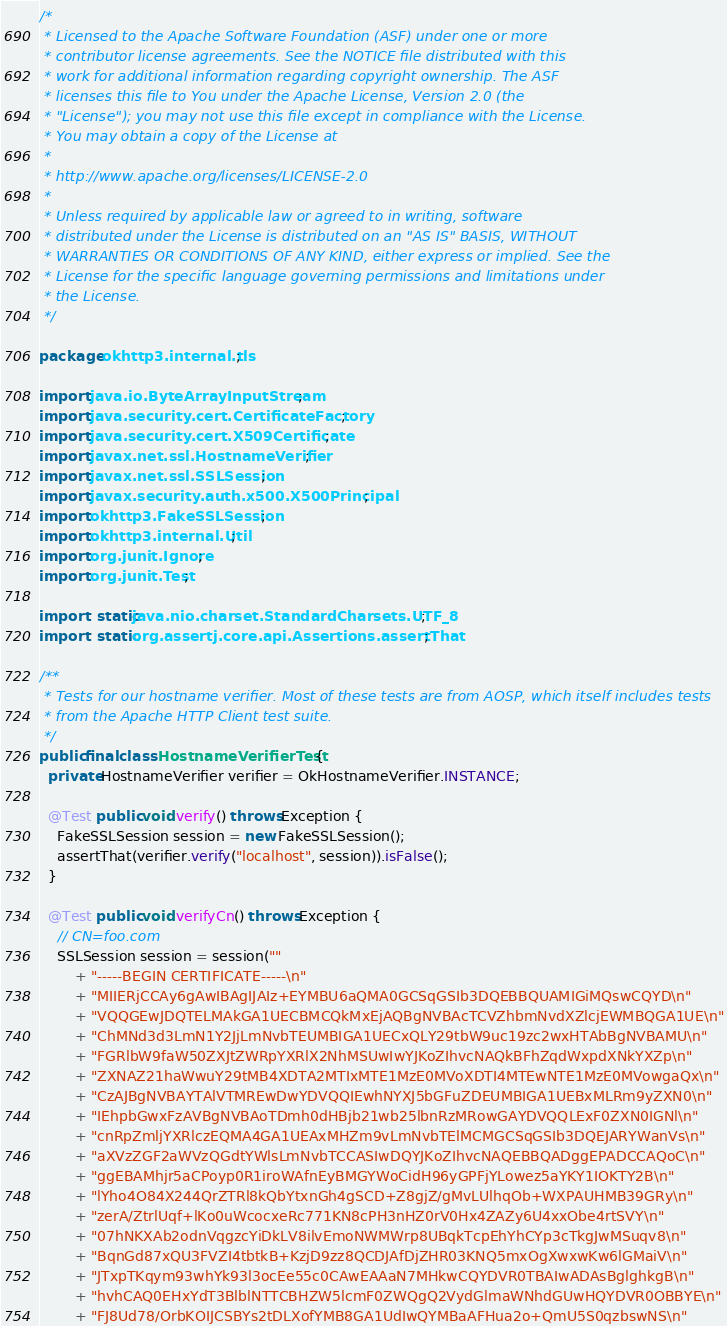<code> <loc_0><loc_0><loc_500><loc_500><_Java_>/*
 * Licensed to the Apache Software Foundation (ASF) under one or more
 * contributor license agreements. See the NOTICE file distributed with this
 * work for additional information regarding copyright ownership. The ASF
 * licenses this file to You under the Apache License, Version 2.0 (the
 * "License"); you may not use this file except in compliance with the License.
 * You may obtain a copy of the License at
 *
 * http://www.apache.org/licenses/LICENSE-2.0
 *
 * Unless required by applicable law or agreed to in writing, software
 * distributed under the License is distributed on an "AS IS" BASIS, WITHOUT
 * WARRANTIES OR CONDITIONS OF ANY KIND, either express or implied. See the
 * License for the specific language governing permissions and limitations under
 * the License.
 */

package okhttp3.internal.tls;

import java.io.ByteArrayInputStream;
import java.security.cert.CertificateFactory;
import java.security.cert.X509Certificate;
import javax.net.ssl.HostnameVerifier;
import javax.net.ssl.SSLSession;
import javax.security.auth.x500.X500Principal;
import okhttp3.FakeSSLSession;
import okhttp3.internal.Util;
import org.junit.Ignore;
import org.junit.Test;

import static java.nio.charset.StandardCharsets.UTF_8;
import static org.assertj.core.api.Assertions.assertThat;

/**
 * Tests for our hostname verifier. Most of these tests are from AOSP, which itself includes tests
 * from the Apache HTTP Client test suite.
 */
public final class HostnameVerifierTest {
  private HostnameVerifier verifier = OkHostnameVerifier.INSTANCE;

  @Test public void verify() throws Exception {
    FakeSSLSession session = new FakeSSLSession();
    assertThat(verifier.verify("localhost", session)).isFalse();
  }

  @Test public void verifyCn() throws Exception {
    // CN=foo.com
    SSLSession session = session(""
        + "-----BEGIN CERTIFICATE-----\n"
        + "MIIERjCCAy6gAwIBAgIJAIz+EYMBU6aQMA0GCSqGSIb3DQEBBQUAMIGiMQswCQYD\n"
        + "VQQGEwJDQTELMAkGA1UECBMCQkMxEjAQBgNVBAcTCVZhbmNvdXZlcjEWMBQGA1UE\n"
        + "ChMNd3d3LmN1Y2JjLmNvbTEUMBIGA1UECxQLY29tbW9uc19zc2wxHTAbBgNVBAMU\n"
        + "FGRlbW9faW50ZXJtZWRpYXRlX2NhMSUwIwYJKoZIhvcNAQkBFhZqdWxpdXNkYXZp\n"
        + "ZXNAZ21haWwuY29tMB4XDTA2MTIxMTE1MzE0MVoXDTI4MTEwNTE1MzE0MVowgaQx\n"
        + "CzAJBgNVBAYTAlVTMREwDwYDVQQIEwhNYXJ5bGFuZDEUMBIGA1UEBxMLRm9yZXN0\n"
        + "IEhpbGwxFzAVBgNVBAoTDmh0dHBjb21wb25lbnRzMRowGAYDVQQLExF0ZXN0IGNl\n"
        + "cnRpZmljYXRlczEQMA4GA1UEAxMHZm9vLmNvbTElMCMGCSqGSIb3DQEJARYWanVs\n"
        + "aXVzZGF2aWVzQGdtYWlsLmNvbTCCASIwDQYJKoZIhvcNAQEBBQADggEPADCCAQoC\n"
        + "ggEBAMhjr5aCPoyp0R1iroWAfnEyBMGYWoCidH96yGPFjYLowez5aYKY1IOKTY2B\n"
        + "lYho4O84X244QrZTRl8kQbYtxnGh4gSCD+Z8gjZ/gMvLUlhqOb+WXPAUHMB39GRy\n"
        + "zerA/ZtrlUqf+lKo0uWcocxeRc771KN8cPH3nHZ0rV0Hx4ZAZy6U4xxObe4rtSVY\n"
        + "07hNKXAb2odnVqgzcYiDkLV8ilvEmoNWMWrp8UBqkTcpEhYhCYp3cTkgJwMSuqv8\n"
        + "BqnGd87xQU3FVZI4tbtkB+KzjD9zz8QCDJAfDjZHR03KNQ5mxOgXwxwKw6lGMaiV\n"
        + "JTxpTKqym93whYk93l3ocEe55c0CAwEAAaN7MHkwCQYDVR0TBAIwADAsBglghkgB\n"
        + "hvhCAQ0EHxYdT3BlblNTTCBHZW5lcmF0ZWQgQ2VydGlmaWNhdGUwHQYDVR0OBBYE\n"
        + "FJ8Ud78/OrbKOIJCSBYs2tDLXofYMB8GA1UdIwQYMBaAFHua2o+QmU5S0qzbswNS\n"</code> 